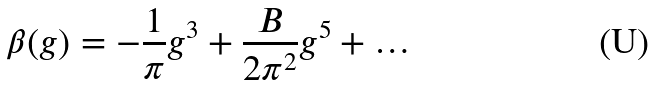<formula> <loc_0><loc_0><loc_500><loc_500>\beta ( g ) = - \frac { 1 } { \pi } g ^ { 3 } + \frac { B } { 2 \pi ^ { 2 } } g ^ { 5 } + \dots</formula> 